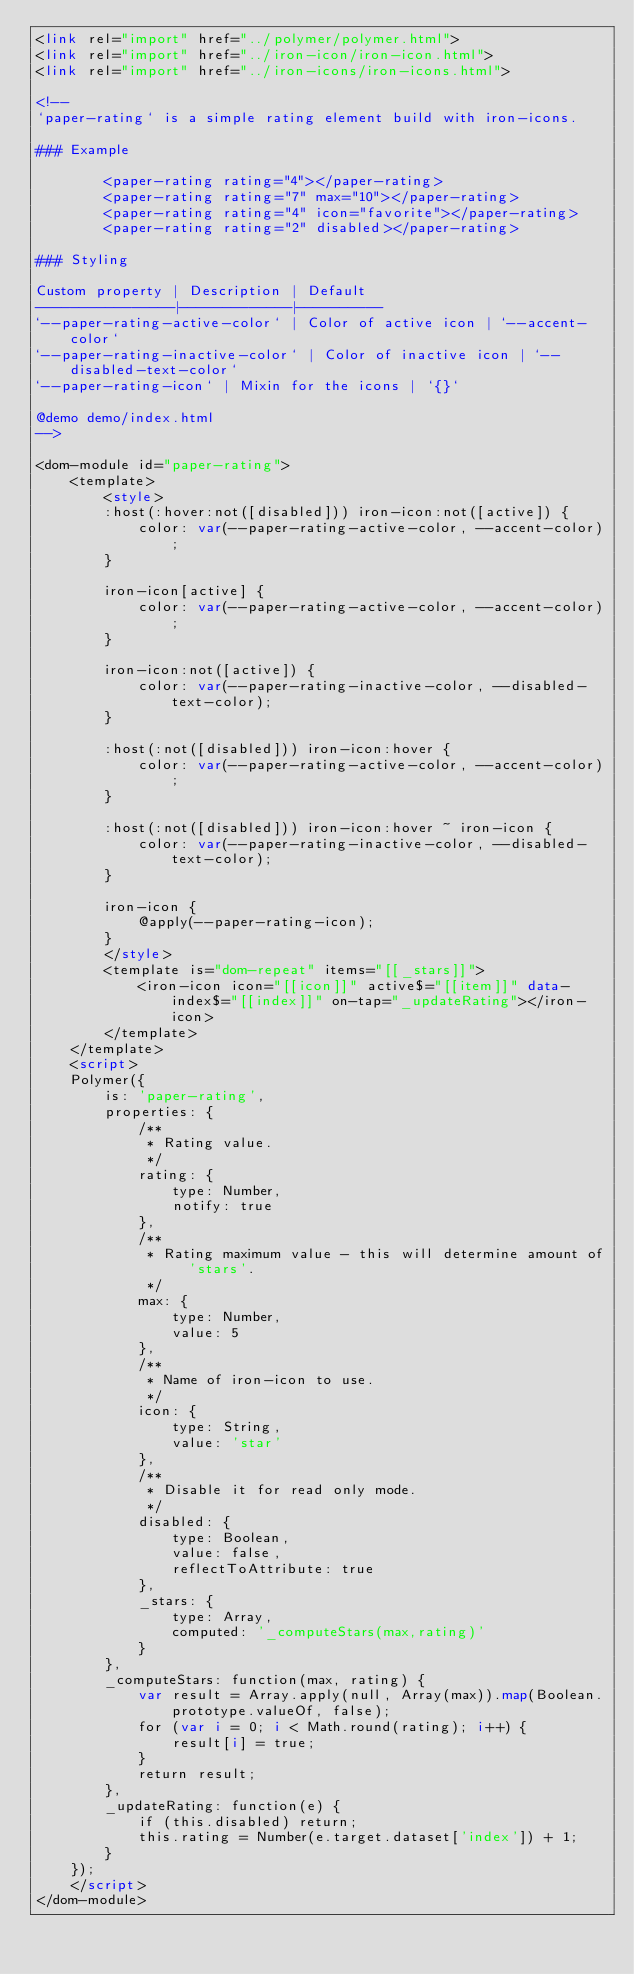Convert code to text. <code><loc_0><loc_0><loc_500><loc_500><_HTML_><link rel="import" href="../polymer/polymer.html">
<link rel="import" href="../iron-icon/iron-icon.html">
<link rel="import" href="../iron-icons/iron-icons.html">

<!--
`paper-rating` is a simple rating element build with iron-icons.

### Example

        <paper-rating rating="4"></paper-rating>
        <paper-rating rating="7" max="10"></paper-rating>
        <paper-rating rating="4" icon="favorite"></paper-rating>
        <paper-rating rating="2" disabled></paper-rating>

### Styling

Custom property | Description | Default
----------------|-------------|----------
`--paper-rating-active-color` | Color of active icon | `--accent-color`
`--paper-rating-inactive-color` | Color of inactive icon | `--disabled-text-color`
`--paper-rating-icon` | Mixin for the icons | `{}`

@demo demo/index.html
-->

<dom-module id="paper-rating">
    <template>
        <style>
        :host(:hover:not([disabled])) iron-icon:not([active]) {
            color: var(--paper-rating-active-color, --accent-color);
        }

        iron-icon[active] {
            color: var(--paper-rating-active-color, --accent-color);
        }

        iron-icon:not([active]) {
            color: var(--paper-rating-inactive-color, --disabled-text-color);
        }

        :host(:not([disabled])) iron-icon:hover {
            color: var(--paper-rating-active-color, --accent-color);
        }

        :host(:not([disabled])) iron-icon:hover ~ iron-icon {
            color: var(--paper-rating-inactive-color, --disabled-text-color);
        }

        iron-icon {
            @apply(--paper-rating-icon);
        }
        </style>
        <template is="dom-repeat" items="[[_stars]]">
            <iron-icon icon="[[icon]]" active$="[[item]]" data-index$="[[index]]" on-tap="_updateRating"></iron-icon>
        </template>
    </template>
    <script>
    Polymer({
        is: 'paper-rating',
        properties: {
            /**
             * Rating value.
             */
            rating: {
                type: Number,
                notify: true
            },
            /**
             * Rating maximum value - this will determine amount of 'stars'.
             */
            max: {
                type: Number,
                value: 5
            },
            /**
             * Name of iron-icon to use.
             */
            icon: {
                type: String,
                value: 'star'
            },
            /**
             * Disable it for read only mode.
             */
            disabled: {
                type: Boolean,
                value: false,
                reflectToAttribute: true
            },
            _stars: {
                type: Array,
                computed: '_computeStars(max,rating)'
            }
        },
        _computeStars: function(max, rating) {
            var result = Array.apply(null, Array(max)).map(Boolean.prototype.valueOf, false);
            for (var i = 0; i < Math.round(rating); i++) {
                result[i] = true;
            }
            return result;
        },
        _updateRating: function(e) {
            if (this.disabled) return;
            this.rating = Number(e.target.dataset['index']) + 1;
        }
    });
    </script>
</dom-module>
</code> 